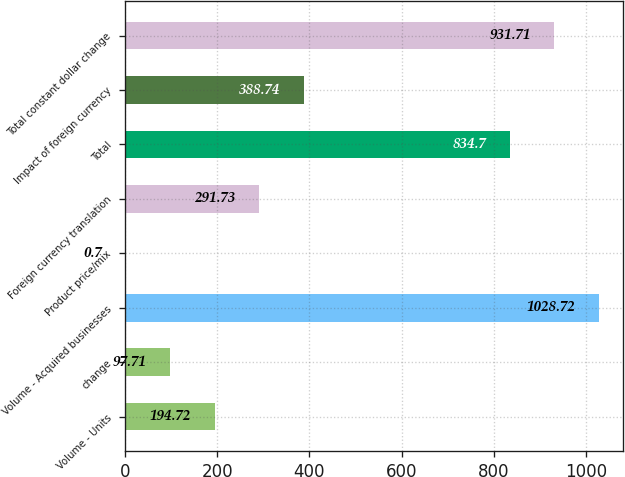Convert chart to OTSL. <chart><loc_0><loc_0><loc_500><loc_500><bar_chart><fcel>Volume - Units<fcel>change<fcel>Volume - Acquired businesses<fcel>Product price/mix<fcel>Foreign currency translation<fcel>Total<fcel>Impact of foreign currency<fcel>Total constant dollar change<nl><fcel>194.72<fcel>97.71<fcel>1028.72<fcel>0.7<fcel>291.73<fcel>834.7<fcel>388.74<fcel>931.71<nl></chart> 